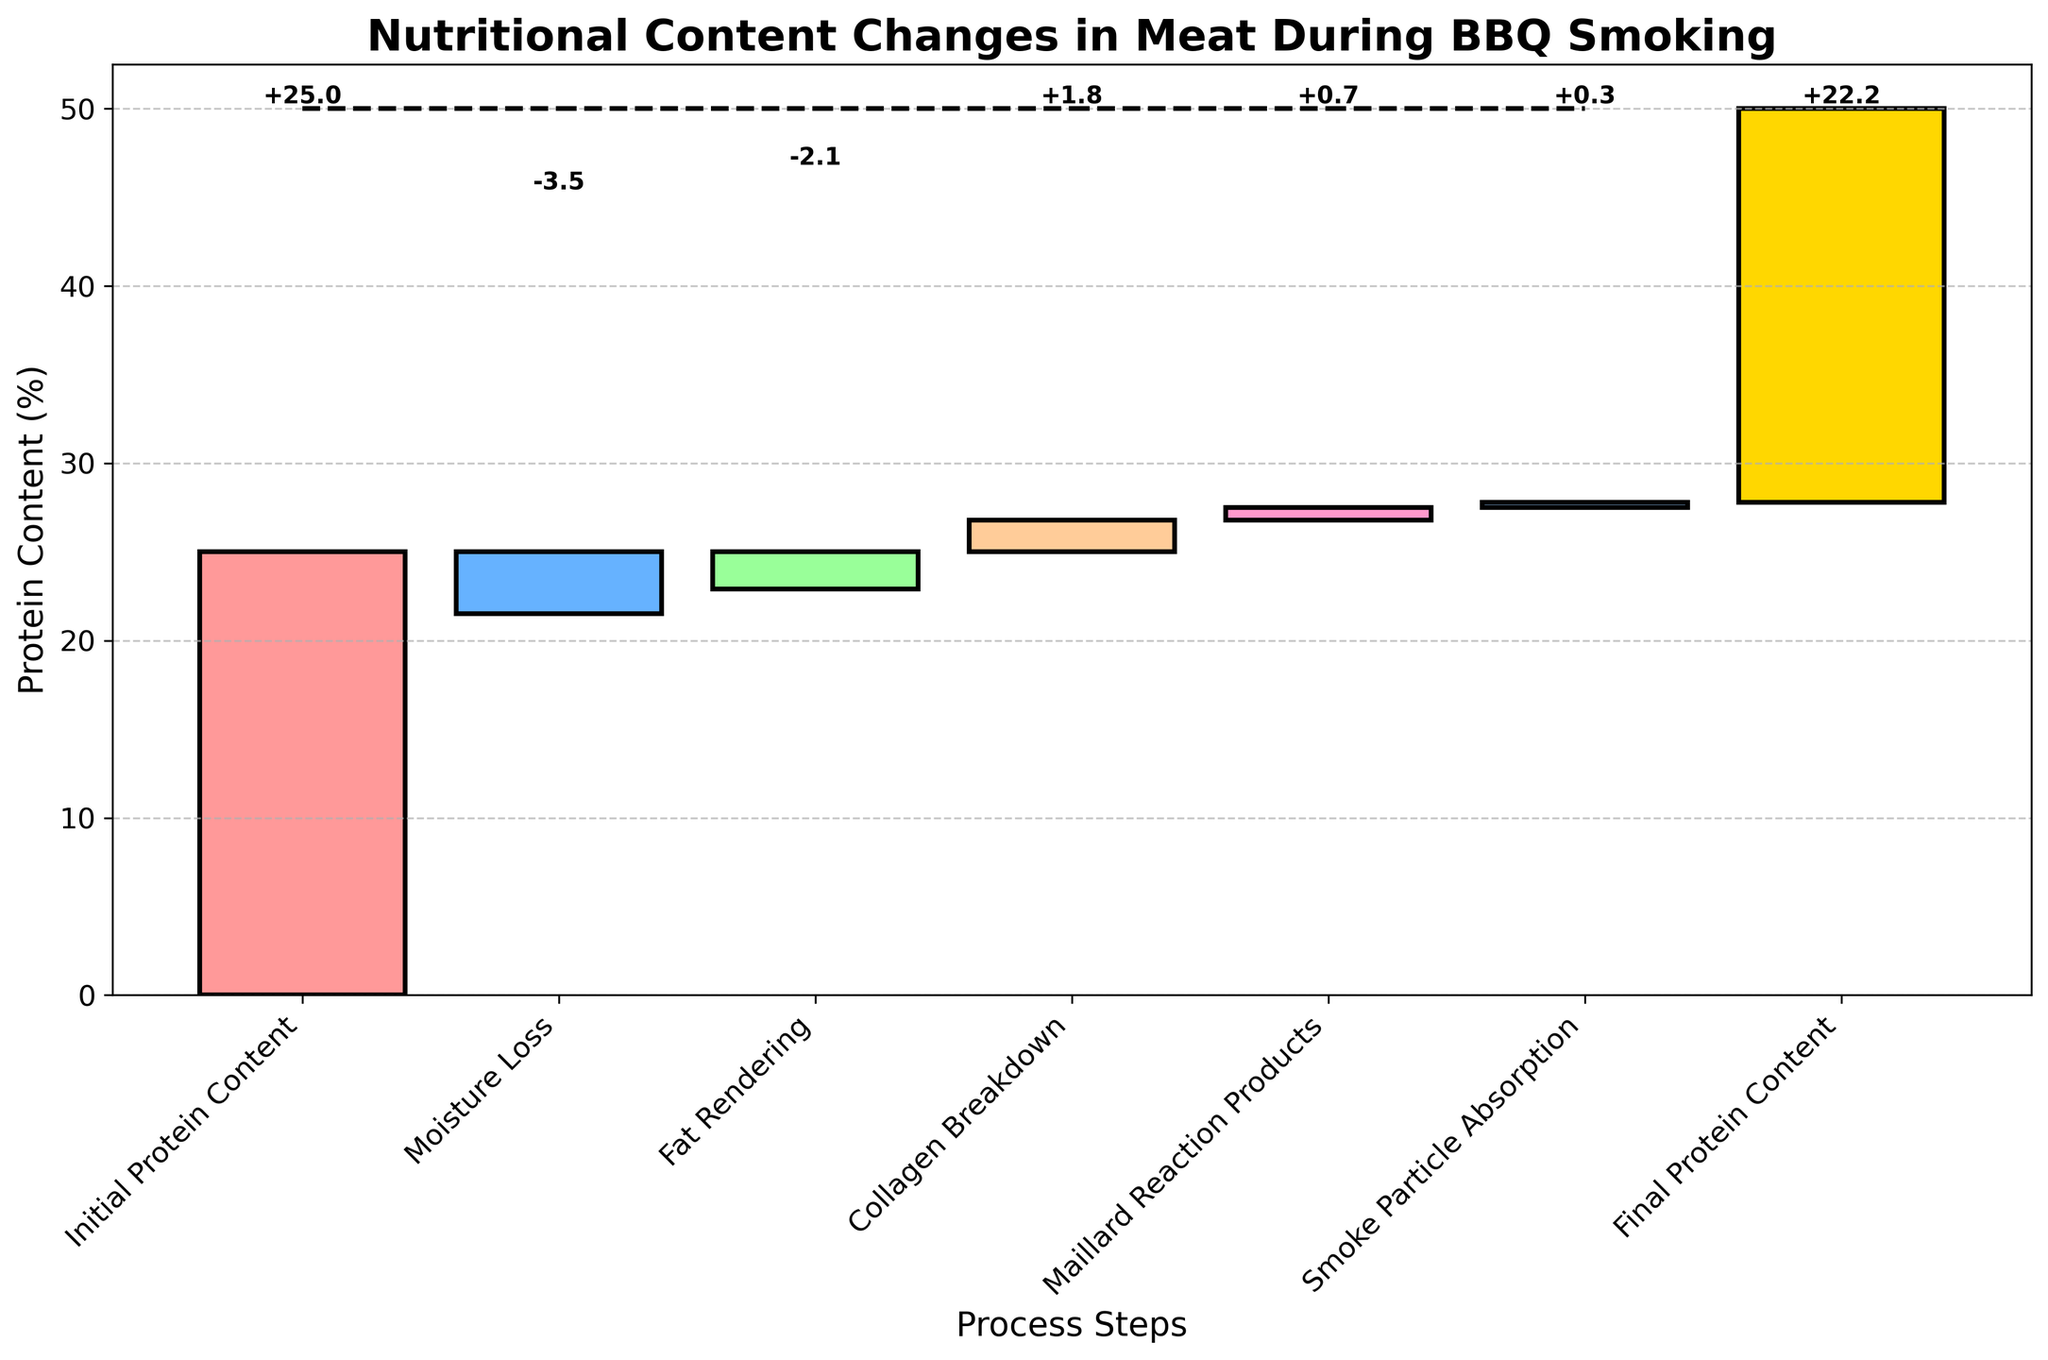What's the title of the chart? The title is prominently displayed at the top of the chart, indicating the main subject of the visual information.
Answer: Nutritional Content Changes in Meat During BBQ Smoking What does the chart measure on the y-axis? The y-axis label states the measurement unit for the values being presented in the chart.
Answer: Protein Content (%) How many process steps are shown in the chart? The x-axis contains tick labels representing the different stages involved in the BBQ smoking process. Counting these gives us the total number of process steps.
Answer: 7 What is the initial protein content? The first bar in the chart clearly represents the initial protein content, which is labeled on the x-axis.
Answer: 25 What is the final protein content? The last bar in the chart represents the final protein content, which can be read directly from the x-axis label.
Answer: 22.2 Which process step causes the largest decrease in protein content? By comparing the negative values in the bars, we identify which process step has the most significant reduction effect on protein content.
Answer: Moisture Loss How much protein content is lost due to moisture loss and fat rendering combined? The chart displays the values for moisture loss and fat rendering; their combined effect is the sum of these two values: -3.5 + (-2.1).
Answer: -5.6 Which process step results in the smallest change in protein content? Comparing all the presented values in the chart, the smallest absolute change in protein content is determined.
Answer: Smoke Particle Absorption How does collagen breakdown affect the protein content? Checking the bar that represents collagen breakdown, we see whether it is positive or negative and its corresponding value.
Answer: Increases by 1.8 Rank the process steps from most positive to most negative impact on protein content. Arranging the process steps based on their values from the most significant positive impact to the most significant negative impact.
Answer: Collagen Breakdown, Maillard Reaction Products, Smoke Particle Absorption, Fat Rendering, Moisture Loss 